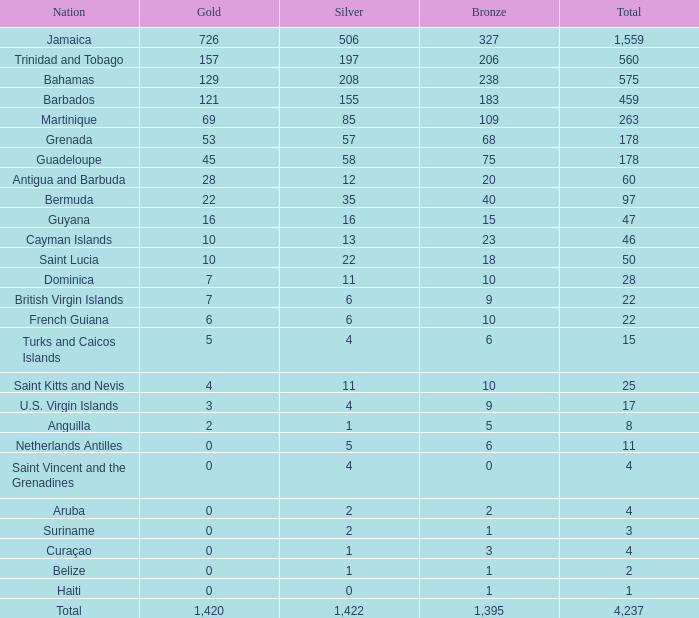What is noted as the peak silver that also includes a gold of 4 and a total surpassing 25? None. 